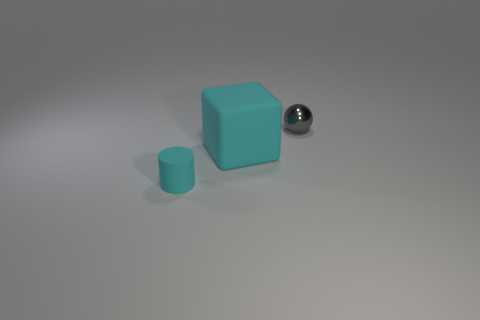Add 2 large objects. How many objects exist? 5 Subtract all red cylinders. Subtract all red cubes. How many cylinders are left? 1 Subtract all cyan spheres. How many blue blocks are left? 0 Subtract all gray things. Subtract all tiny things. How many objects are left? 0 Add 1 cyan objects. How many cyan objects are left? 3 Add 3 big purple metal objects. How many big purple metal objects exist? 3 Subtract 0 green cylinders. How many objects are left? 3 Subtract all spheres. How many objects are left? 2 